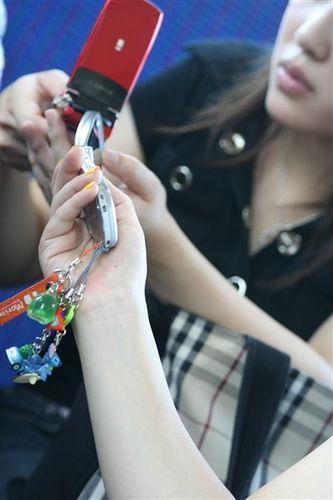How many people can you see?
Give a very brief answer. 2. 